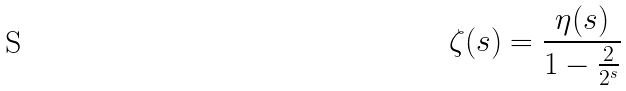Convert formula to latex. <formula><loc_0><loc_0><loc_500><loc_500>\zeta ( s ) = \frac { \eta ( s ) } { 1 - \frac { 2 } { 2 ^ { s } } }</formula> 